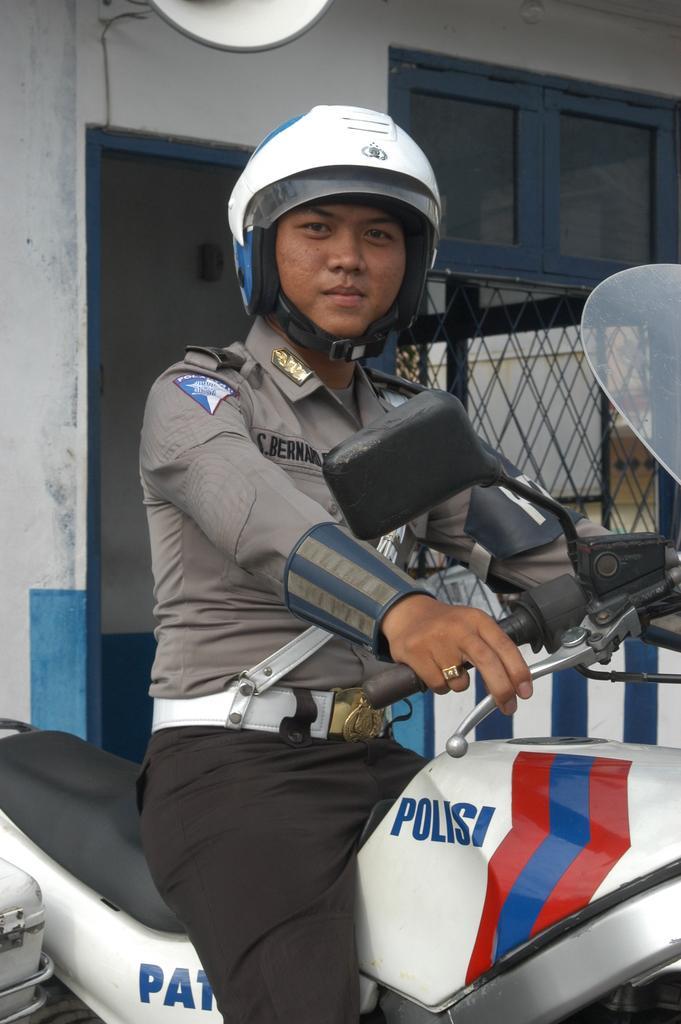Can you describe this image briefly? In this image we can see a person wearing uniform is sitting on the bike. 